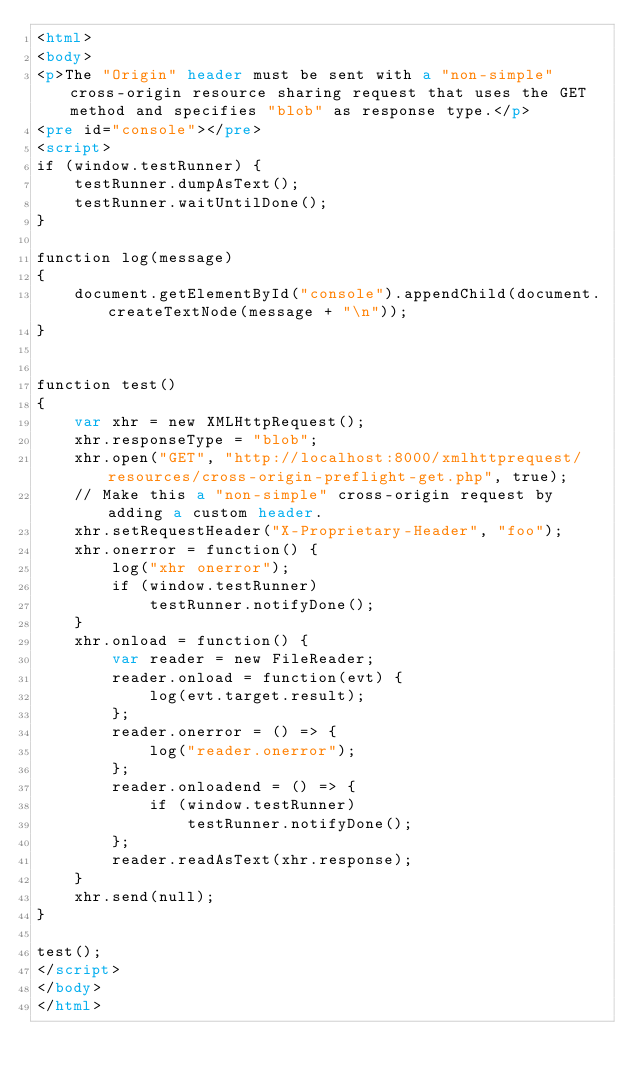Convert code to text. <code><loc_0><loc_0><loc_500><loc_500><_HTML_><html>
<body>
<p>The "Origin" header must be sent with a "non-simple" cross-origin resource sharing request that uses the GET method and specifies "blob" as response type.</p>
<pre id="console"></pre>
<script>
if (window.testRunner) {
    testRunner.dumpAsText();
    testRunner.waitUntilDone();
}

function log(message)
{
    document.getElementById("console").appendChild(document.createTextNode(message + "\n"));
}


function test()
{
    var xhr = new XMLHttpRequest();
    xhr.responseType = "blob";
    xhr.open("GET", "http://localhost:8000/xmlhttprequest/resources/cross-origin-preflight-get.php", true);
    // Make this a "non-simple" cross-origin request by adding a custom header.
    xhr.setRequestHeader("X-Proprietary-Header", "foo");
    xhr.onerror = function() {
        log("xhr onerror");
        if (window.testRunner)
            testRunner.notifyDone();
    }
    xhr.onload = function() {
        var reader = new FileReader;
        reader.onload = function(evt) {
            log(evt.target.result);
        };
        reader.onerror = () => {
            log("reader.onerror");
        };
        reader.onloadend = () => {
            if (window.testRunner)
                testRunner.notifyDone();
        };
        reader.readAsText(xhr.response);
    }
    xhr.send(null);
}

test();
</script>
</body>
</html>
</code> 